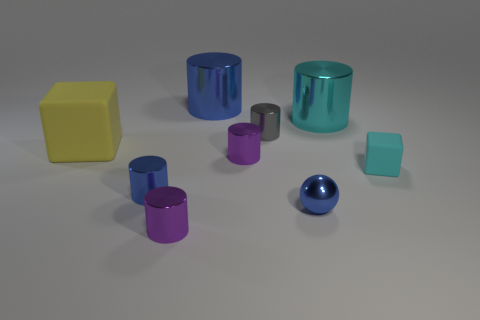Subtract all cyan cylinders. How many cylinders are left? 5 Subtract all purple cylinders. How many cylinders are left? 4 Subtract all cyan cylinders. Subtract all yellow balls. How many cylinders are left? 5 Add 1 large blue cylinders. How many objects exist? 10 Subtract all spheres. How many objects are left? 8 Subtract all big blue shiny things. Subtract all blue spheres. How many objects are left? 7 Add 9 small blocks. How many small blocks are left? 10 Add 4 yellow objects. How many yellow objects exist? 5 Subtract 0 brown cubes. How many objects are left? 9 